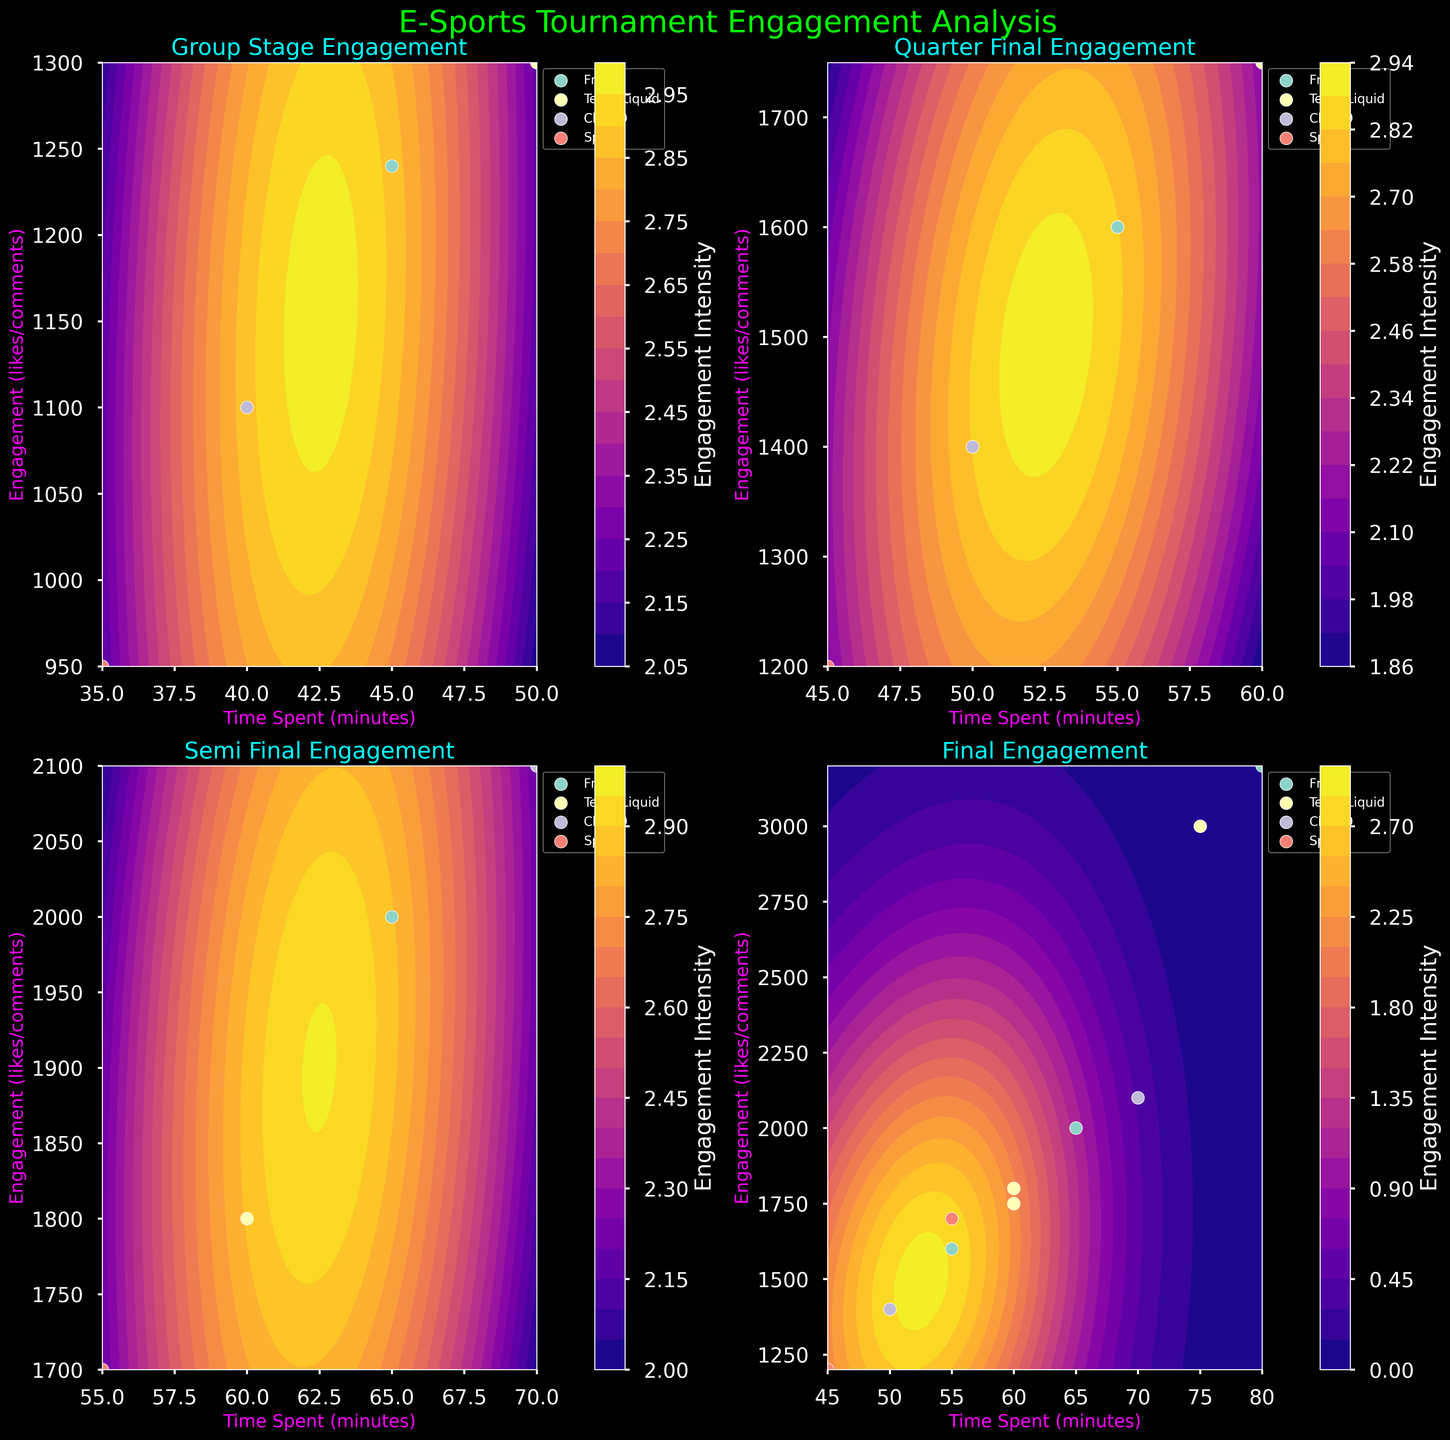Which stage has the highest engagement for Team Liquid? To find the highest engagement for Team Liquid, look at the subplot titles and check the data points corresponding to Team Liquid in each stage. The highest peak in the 'Final' stage subplot indicates the highest engagement.
Answer: Final What color indicates the highest engagement intensity in the Group Stage subplot? Look at the color bar on the side of the Group Stage subplot. The side with the label 'Engagement Intensity' shows colors representing different levels. The color at the top of the scale (closer to a brighter shade) represents the highest engagement intensity.
Answer: Brightest yellow Is there any team that shows a significant increase in engagement from the Quarter Final to the Semi Final? By comparing the engagement points of each team in the Quarter Final and Semi Final subplots, we observe that Cloud9 improves from 1400 likes/comments in Quarter Final 2 to 2100 likes/comments in Semi Final 1.
Answer: Yes, Cloud9 Which subplot has the team with the highest single engagement? Identify the subplots and compare scattered points' engagement values. The 'Final' subplot shows the highest engagement with Fnatic reaching 3200 likes/comments.
Answer: Final How does the engagement intensity change as teams progress from the Group Stage to the Final? Observe the color gradient and contour densities across the subplots from Group Stage to Final. Engagement intensity generally increases as seen from darker to lighter colors moving from Group Stage to Finals.
Answer: Increases How much time does Team Liquid spend on average during the tournament stages? Add Team Liquid's time spent across all stages (50 + 60 + 60 + 75 = 245) and divide by the number of stages (4). Hence, 245/4 = 61.25 minutes.
Answer: 61.25 minutes Which team has the lowest engagement in the Quarter Final stage? In both Quarter Final subplots, check the data points and identify the team with the lowest engagement. Team Splyce has the lowest engagement with 1200 likes/comments in Quarter Final 2.
Answer: Splyce What is the range of engagement for the teams in the Semi Final? Identify the lowest and highest engagement points in both Semi Final subplots. The range is from Splyce's 1700 to Cloud9's 2100 likes/comments. Thus, the range is 2100 - 1700 = 400.
Answer: 400 Which team consistently shows an increase in engagement across all stages? By analyzing each subplot, note the engagement values and check if engagement increases for each team progressively. Fnatic shows an increase in engagement from 1240 in Group Stage to 1600 in Quarter Final, 2000 in Semi Final, and 3200 in Final.
Answer: Fnatic What other characteristic besides time and engagement does this figure emphasize? Observe the color contour gradients and scattered points. Besides showing time and engagement, the figure emphasizes the intensity of engagement via color density.
Answer: Engagement intensity 